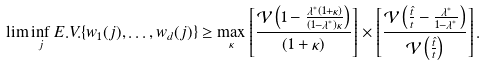<formula> <loc_0><loc_0><loc_500><loc_500>\lim \inf _ { j } E . V . \{ w _ { 1 } ( j ) , \dots , w _ { d } ( j ) \} \geq \max _ { \kappa } \left [ \frac { \mathcal { V } \left ( 1 - \frac { \lambda ^ { * } ( 1 + \kappa ) } { ( 1 - \lambda ^ { * } ) \kappa } \right ) } { ( 1 + \kappa ) } \right ] \times \left [ \frac { \mathcal { V } \left ( \frac { \hat { t } } { t } - \frac { \lambda ^ { * } } { 1 - \lambda ^ { * } } \right ) } { \mathcal { V } \left ( \frac { \hat { t } } { t } \right ) } \right ] .</formula> 